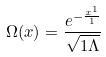<formula> <loc_0><loc_0><loc_500><loc_500>\Omega ( x ) = \frac { e ^ { - \frac { x ^ { 1 } } { 1 } } } { \sqrt { 1 \Lambda } }</formula> 